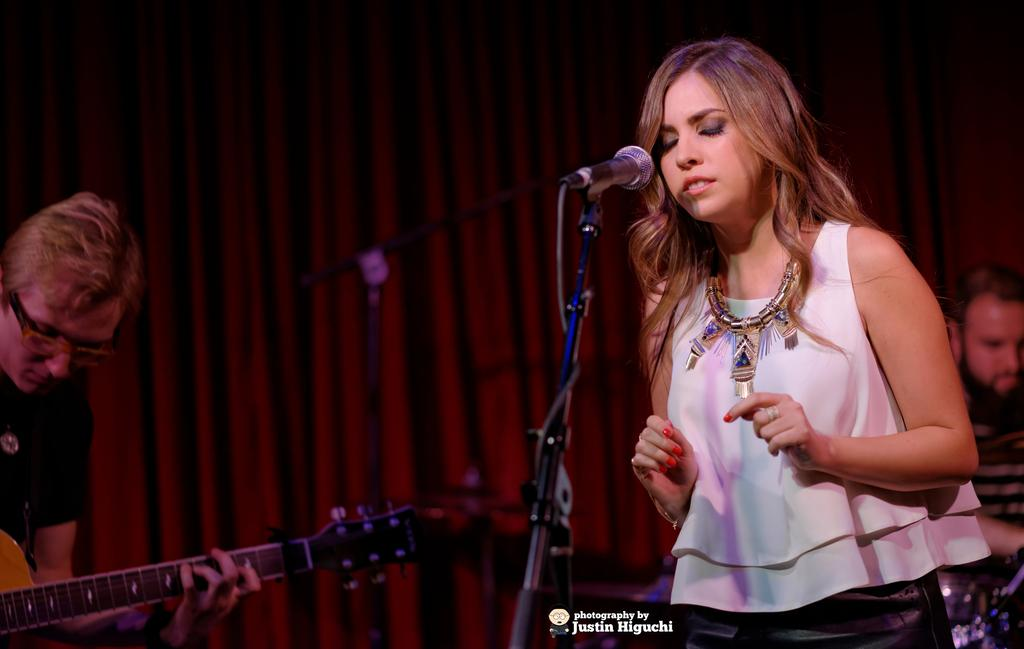Who is the main subject in the image? There is a woman in the image. What is the woman doing in the image? The woman is in front of a mic. Can you describe the background of the image? The background features a man playing a guitar and a red carpet. How many kittens are sitting on the furniture in the image? There are no kittens or furniture present in the image. 